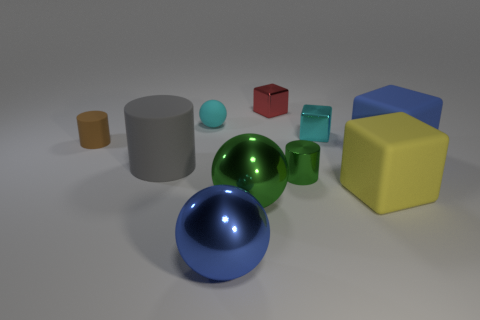What size is the metallic block that is the same color as the tiny ball?
Provide a short and direct response. Small. There is a thing that is the same color as the tiny rubber sphere; what material is it?
Offer a terse response. Metal. Is the size of the blue thing to the left of the red object the same as the small red cube?
Offer a very short reply. No. The tiny shiny cylinder is what color?
Provide a short and direct response. Green. There is a small block that is in front of the small cyan thing that is left of the small metallic cylinder; what is its color?
Provide a short and direct response. Cyan. Is there a big gray cylinder made of the same material as the tiny green object?
Give a very brief answer. No. What is the material of the block that is behind the matte object behind the small matte cylinder?
Keep it short and to the point. Metal. How many small purple objects have the same shape as the large yellow rubber thing?
Offer a very short reply. 0. What is the shape of the small red metal object?
Your response must be concise. Cube. Are there fewer red metallic cylinders than large gray things?
Provide a succinct answer. Yes. 